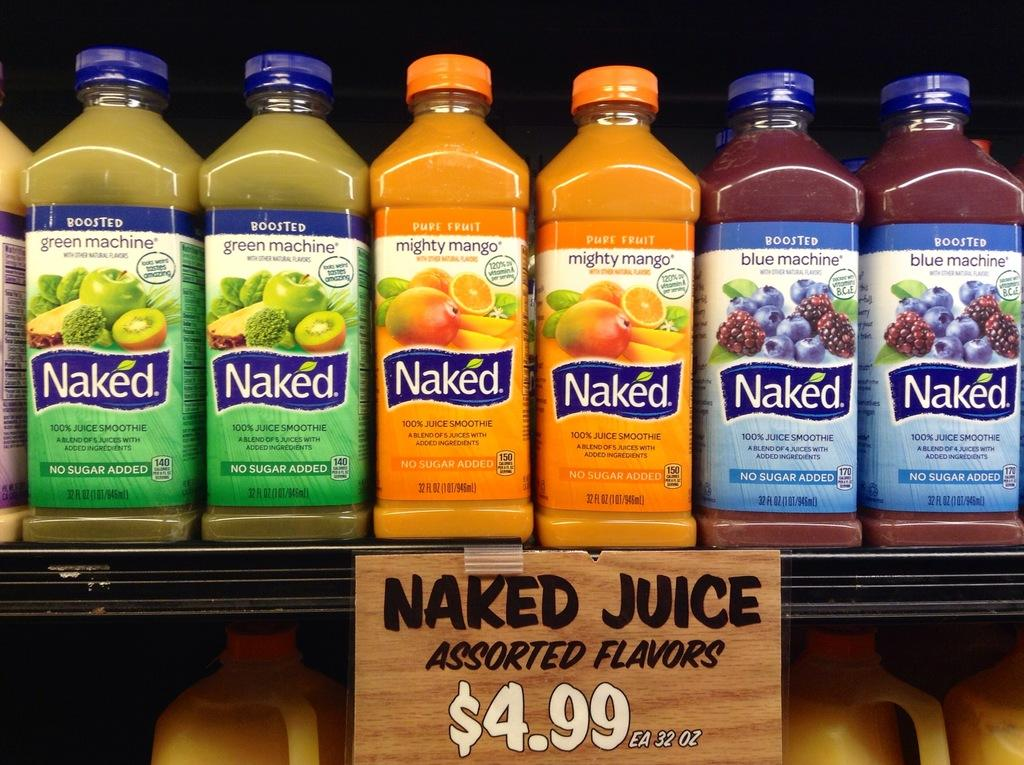What can be found on the shelf in the image? There is a shelf in the image that contains bottles of orange, maroon, and yellow colors. What is written on the labels of the bottles? The bottles are labeled as "naked juices flavors." How much do the juices cost? The price of the juices is $4.99. What type of cloth is used to make the ocean in the image? There is no ocean present in the image, so cloth is not used to make it. 